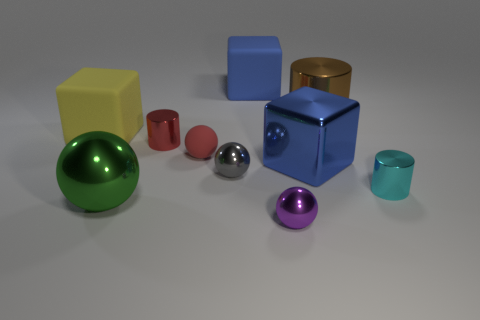Subtract all big blue blocks. How many blocks are left? 1 Subtract all purple cylinders. How many blue cubes are left? 2 Subtract all gray spheres. How many spheres are left? 3 Subtract 1 cylinders. How many cylinders are left? 2 Subtract all cyan spheres. Subtract all brown cylinders. How many spheres are left? 4 Subtract all spheres. How many objects are left? 6 Subtract all brown metallic blocks. Subtract all big blue matte cubes. How many objects are left? 9 Add 1 large things. How many large things are left? 6 Add 9 cyan things. How many cyan things exist? 10 Subtract 1 cyan cylinders. How many objects are left? 9 